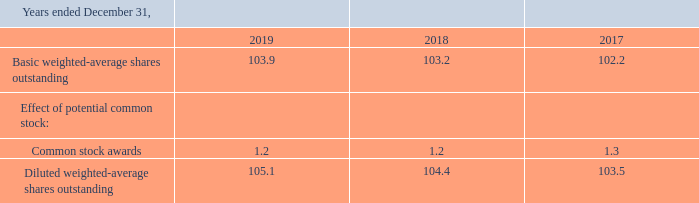Earnings per Share—Basic earnings per share were calculated using net earnings and the weighted-average number of shares of common stock outstanding during the respective year. Diluted earnings per share were calculated using net earnings and the weighted-average number of shares of common stock and potential common stock associated with stock options outstanding during the respective year. The effects of potential common stock were determined using the treasury stock method:
As of and for the years ended December 31, 2019, 2018 and 2017, there were 0.627, 0.724 and 0.478 outstanding stock options, respectively, that were not included in the determination of diluted earnings per share because doing so would have been antidilutive.
How is basic earning per share calculated? Using net earnings and the weighted-average number of shares of common stock outstanding during the respective year. How many outstanding stock options would have been antidilutive for fiscal years 2017 and 2018, respectively? 0.478, 0.724. How are the effects of potential common stock determined? Using the treasury stock method. What is the average of basic weighted-average shares outstanding from 2017 to 2019? (103.9+103.2+102.2)/3 
Answer: 103.1. What is the proportion of basic over diluted weighted-average shares outstanding in 2017? 102.2/103.5 
Answer: 0.99. What is the change in Diluted weighted-average shares outstanding between 2018 and 2019? 105.1-104.4
Answer: 0.7. 